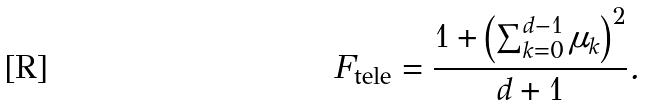Convert formula to latex. <formula><loc_0><loc_0><loc_500><loc_500>F _ { \text {tele} } = \frac { 1 + \left ( \sum _ { k = 0 } ^ { d - 1 } \mu _ { k } \right ) ^ { 2 } } { d + 1 } .</formula> 